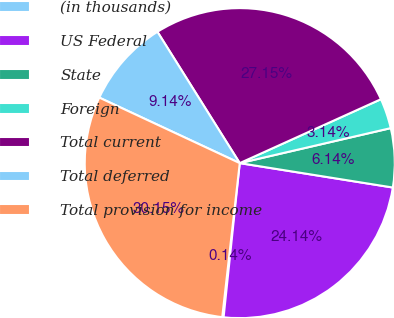Convert chart. <chart><loc_0><loc_0><loc_500><loc_500><pie_chart><fcel>(in thousands)<fcel>US Federal<fcel>State<fcel>Foreign<fcel>Total current<fcel>Total deferred<fcel>Total provision for income<nl><fcel>0.14%<fcel>24.14%<fcel>6.14%<fcel>3.14%<fcel>27.14%<fcel>9.14%<fcel>30.14%<nl></chart> 